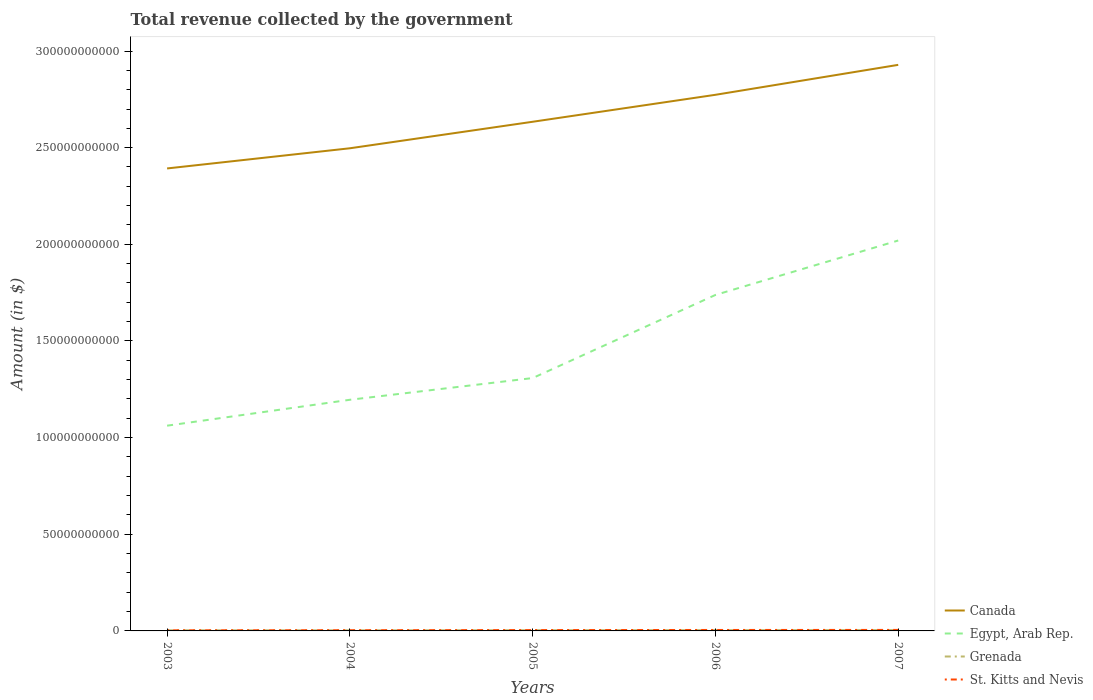How many different coloured lines are there?
Your answer should be compact. 4. Is the number of lines equal to the number of legend labels?
Ensure brevity in your answer.  Yes. Across all years, what is the maximum total revenue collected by the government in St. Kitts and Nevis?
Ensure brevity in your answer.  3.21e+08. In which year was the total revenue collected by the government in St. Kitts and Nevis maximum?
Your answer should be compact. 2003. What is the total total revenue collected by the government in Egypt, Arab Rep. in the graph?
Keep it short and to the point. -1.12e+1. What is the difference between the highest and the second highest total revenue collected by the government in Grenada?
Your response must be concise. 1.28e+08. What is the difference between the highest and the lowest total revenue collected by the government in Canada?
Make the answer very short. 2. Does the graph contain grids?
Keep it short and to the point. No. Where does the legend appear in the graph?
Keep it short and to the point. Bottom right. How are the legend labels stacked?
Provide a short and direct response. Vertical. What is the title of the graph?
Provide a short and direct response. Total revenue collected by the government. Does "Macao" appear as one of the legend labels in the graph?
Your answer should be compact. No. What is the label or title of the Y-axis?
Your answer should be compact. Amount (in $). What is the Amount (in $) in Canada in 2003?
Keep it short and to the point. 2.39e+11. What is the Amount (in $) in Egypt, Arab Rep. in 2003?
Your answer should be compact. 1.06e+11. What is the Amount (in $) in Grenada in 2003?
Offer a terse response. 3.24e+08. What is the Amount (in $) in St. Kitts and Nevis in 2003?
Ensure brevity in your answer.  3.21e+08. What is the Amount (in $) of Canada in 2004?
Provide a succinct answer. 2.50e+11. What is the Amount (in $) of Egypt, Arab Rep. in 2004?
Keep it short and to the point. 1.20e+11. What is the Amount (in $) in Grenada in 2004?
Offer a very short reply. 3.01e+08. What is the Amount (in $) of St. Kitts and Nevis in 2004?
Offer a terse response. 3.65e+08. What is the Amount (in $) of Canada in 2005?
Give a very brief answer. 2.63e+11. What is the Amount (in $) of Egypt, Arab Rep. in 2005?
Provide a short and direct response. 1.31e+11. What is the Amount (in $) of Grenada in 2005?
Keep it short and to the point. 3.60e+08. What is the Amount (in $) in St. Kitts and Nevis in 2005?
Offer a very short reply. 4.34e+08. What is the Amount (in $) of Canada in 2006?
Keep it short and to the point. 2.77e+11. What is the Amount (in $) in Egypt, Arab Rep. in 2006?
Your answer should be very brief. 1.74e+11. What is the Amount (in $) of Grenada in 2006?
Your response must be concise. 3.86e+08. What is the Amount (in $) of St. Kitts and Nevis in 2006?
Your answer should be very brief. 4.92e+08. What is the Amount (in $) of Canada in 2007?
Ensure brevity in your answer.  2.93e+11. What is the Amount (in $) of Egypt, Arab Rep. in 2007?
Provide a short and direct response. 2.02e+11. What is the Amount (in $) of Grenada in 2007?
Ensure brevity in your answer.  4.28e+08. What is the Amount (in $) of St. Kitts and Nevis in 2007?
Keep it short and to the point. 5.16e+08. Across all years, what is the maximum Amount (in $) of Canada?
Offer a very short reply. 2.93e+11. Across all years, what is the maximum Amount (in $) in Egypt, Arab Rep.?
Ensure brevity in your answer.  2.02e+11. Across all years, what is the maximum Amount (in $) in Grenada?
Provide a succinct answer. 4.28e+08. Across all years, what is the maximum Amount (in $) in St. Kitts and Nevis?
Provide a succinct answer. 5.16e+08. Across all years, what is the minimum Amount (in $) of Canada?
Your answer should be very brief. 2.39e+11. Across all years, what is the minimum Amount (in $) of Egypt, Arab Rep.?
Give a very brief answer. 1.06e+11. Across all years, what is the minimum Amount (in $) in Grenada?
Offer a terse response. 3.01e+08. Across all years, what is the minimum Amount (in $) of St. Kitts and Nevis?
Ensure brevity in your answer.  3.21e+08. What is the total Amount (in $) in Canada in the graph?
Your response must be concise. 1.32e+12. What is the total Amount (in $) of Egypt, Arab Rep. in the graph?
Provide a succinct answer. 7.32e+11. What is the total Amount (in $) in Grenada in the graph?
Offer a terse response. 1.80e+09. What is the total Amount (in $) of St. Kitts and Nevis in the graph?
Offer a very short reply. 2.13e+09. What is the difference between the Amount (in $) in Canada in 2003 and that in 2004?
Your response must be concise. -1.04e+1. What is the difference between the Amount (in $) in Egypt, Arab Rep. in 2003 and that in 2004?
Offer a terse response. -1.34e+1. What is the difference between the Amount (in $) in Grenada in 2003 and that in 2004?
Offer a terse response. 2.27e+07. What is the difference between the Amount (in $) in St. Kitts and Nevis in 2003 and that in 2004?
Offer a very short reply. -4.39e+07. What is the difference between the Amount (in $) of Canada in 2003 and that in 2005?
Provide a short and direct response. -2.41e+1. What is the difference between the Amount (in $) of Egypt, Arab Rep. in 2003 and that in 2005?
Offer a very short reply. -2.46e+1. What is the difference between the Amount (in $) of Grenada in 2003 and that in 2005?
Make the answer very short. -3.62e+07. What is the difference between the Amount (in $) of St. Kitts and Nevis in 2003 and that in 2005?
Give a very brief answer. -1.12e+08. What is the difference between the Amount (in $) in Canada in 2003 and that in 2006?
Your response must be concise. -3.81e+1. What is the difference between the Amount (in $) of Egypt, Arab Rep. in 2003 and that in 2006?
Give a very brief answer. -6.76e+1. What is the difference between the Amount (in $) in Grenada in 2003 and that in 2006?
Offer a very short reply. -6.24e+07. What is the difference between the Amount (in $) of St. Kitts and Nevis in 2003 and that in 2006?
Your response must be concise. -1.70e+08. What is the difference between the Amount (in $) in Canada in 2003 and that in 2007?
Give a very brief answer. -5.36e+1. What is the difference between the Amount (in $) of Egypt, Arab Rep. in 2003 and that in 2007?
Keep it short and to the point. -9.58e+1. What is the difference between the Amount (in $) in Grenada in 2003 and that in 2007?
Your response must be concise. -1.05e+08. What is the difference between the Amount (in $) in St. Kitts and Nevis in 2003 and that in 2007?
Provide a short and direct response. -1.95e+08. What is the difference between the Amount (in $) of Canada in 2004 and that in 2005?
Provide a short and direct response. -1.37e+1. What is the difference between the Amount (in $) of Egypt, Arab Rep. in 2004 and that in 2005?
Offer a very short reply. -1.12e+1. What is the difference between the Amount (in $) of Grenada in 2004 and that in 2005?
Your answer should be compact. -5.89e+07. What is the difference between the Amount (in $) of St. Kitts and Nevis in 2004 and that in 2005?
Offer a terse response. -6.85e+07. What is the difference between the Amount (in $) of Canada in 2004 and that in 2006?
Provide a short and direct response. -2.77e+1. What is the difference between the Amount (in $) of Egypt, Arab Rep. in 2004 and that in 2006?
Offer a very short reply. -5.42e+1. What is the difference between the Amount (in $) of Grenada in 2004 and that in 2006?
Keep it short and to the point. -8.51e+07. What is the difference between the Amount (in $) in St. Kitts and Nevis in 2004 and that in 2006?
Provide a short and direct response. -1.26e+08. What is the difference between the Amount (in $) of Canada in 2004 and that in 2007?
Offer a very short reply. -4.32e+1. What is the difference between the Amount (in $) in Egypt, Arab Rep. in 2004 and that in 2007?
Keep it short and to the point. -8.24e+1. What is the difference between the Amount (in $) of Grenada in 2004 and that in 2007?
Offer a very short reply. -1.28e+08. What is the difference between the Amount (in $) in St. Kitts and Nevis in 2004 and that in 2007?
Offer a very short reply. -1.51e+08. What is the difference between the Amount (in $) in Canada in 2005 and that in 2006?
Ensure brevity in your answer.  -1.40e+1. What is the difference between the Amount (in $) in Egypt, Arab Rep. in 2005 and that in 2006?
Ensure brevity in your answer.  -4.30e+1. What is the difference between the Amount (in $) in Grenada in 2005 and that in 2006?
Provide a short and direct response. -2.62e+07. What is the difference between the Amount (in $) of St. Kitts and Nevis in 2005 and that in 2006?
Provide a short and direct response. -5.77e+07. What is the difference between the Amount (in $) in Canada in 2005 and that in 2007?
Your answer should be very brief. -2.94e+1. What is the difference between the Amount (in $) in Egypt, Arab Rep. in 2005 and that in 2007?
Provide a succinct answer. -7.12e+1. What is the difference between the Amount (in $) of Grenada in 2005 and that in 2007?
Make the answer very short. -6.86e+07. What is the difference between the Amount (in $) of St. Kitts and Nevis in 2005 and that in 2007?
Your answer should be compact. -8.23e+07. What is the difference between the Amount (in $) in Canada in 2006 and that in 2007?
Your answer should be very brief. -1.55e+1. What is the difference between the Amount (in $) of Egypt, Arab Rep. in 2006 and that in 2007?
Make the answer very short. -2.82e+1. What is the difference between the Amount (in $) of Grenada in 2006 and that in 2007?
Offer a terse response. -4.24e+07. What is the difference between the Amount (in $) in St. Kitts and Nevis in 2006 and that in 2007?
Your response must be concise. -2.46e+07. What is the difference between the Amount (in $) in Canada in 2003 and the Amount (in $) in Egypt, Arab Rep. in 2004?
Offer a very short reply. 1.20e+11. What is the difference between the Amount (in $) in Canada in 2003 and the Amount (in $) in Grenada in 2004?
Offer a very short reply. 2.39e+11. What is the difference between the Amount (in $) of Canada in 2003 and the Amount (in $) of St. Kitts and Nevis in 2004?
Offer a terse response. 2.39e+11. What is the difference between the Amount (in $) of Egypt, Arab Rep. in 2003 and the Amount (in $) of Grenada in 2004?
Your answer should be very brief. 1.06e+11. What is the difference between the Amount (in $) in Egypt, Arab Rep. in 2003 and the Amount (in $) in St. Kitts and Nevis in 2004?
Keep it short and to the point. 1.06e+11. What is the difference between the Amount (in $) in Grenada in 2003 and the Amount (in $) in St. Kitts and Nevis in 2004?
Make the answer very short. -4.17e+07. What is the difference between the Amount (in $) in Canada in 2003 and the Amount (in $) in Egypt, Arab Rep. in 2005?
Offer a terse response. 1.08e+11. What is the difference between the Amount (in $) in Canada in 2003 and the Amount (in $) in Grenada in 2005?
Provide a succinct answer. 2.39e+11. What is the difference between the Amount (in $) in Canada in 2003 and the Amount (in $) in St. Kitts and Nevis in 2005?
Your answer should be very brief. 2.39e+11. What is the difference between the Amount (in $) of Egypt, Arab Rep. in 2003 and the Amount (in $) of Grenada in 2005?
Your answer should be compact. 1.06e+11. What is the difference between the Amount (in $) of Egypt, Arab Rep. in 2003 and the Amount (in $) of St. Kitts and Nevis in 2005?
Make the answer very short. 1.06e+11. What is the difference between the Amount (in $) in Grenada in 2003 and the Amount (in $) in St. Kitts and Nevis in 2005?
Make the answer very short. -1.10e+08. What is the difference between the Amount (in $) of Canada in 2003 and the Amount (in $) of Egypt, Arab Rep. in 2006?
Make the answer very short. 6.54e+1. What is the difference between the Amount (in $) of Canada in 2003 and the Amount (in $) of Grenada in 2006?
Your response must be concise. 2.39e+11. What is the difference between the Amount (in $) of Canada in 2003 and the Amount (in $) of St. Kitts and Nevis in 2006?
Provide a succinct answer. 2.39e+11. What is the difference between the Amount (in $) of Egypt, Arab Rep. in 2003 and the Amount (in $) of Grenada in 2006?
Ensure brevity in your answer.  1.06e+11. What is the difference between the Amount (in $) in Egypt, Arab Rep. in 2003 and the Amount (in $) in St. Kitts and Nevis in 2006?
Provide a succinct answer. 1.06e+11. What is the difference between the Amount (in $) in Grenada in 2003 and the Amount (in $) in St. Kitts and Nevis in 2006?
Your answer should be compact. -1.68e+08. What is the difference between the Amount (in $) in Canada in 2003 and the Amount (in $) in Egypt, Arab Rep. in 2007?
Provide a succinct answer. 3.73e+1. What is the difference between the Amount (in $) of Canada in 2003 and the Amount (in $) of Grenada in 2007?
Provide a succinct answer. 2.39e+11. What is the difference between the Amount (in $) in Canada in 2003 and the Amount (in $) in St. Kitts and Nevis in 2007?
Keep it short and to the point. 2.39e+11. What is the difference between the Amount (in $) in Egypt, Arab Rep. in 2003 and the Amount (in $) in Grenada in 2007?
Provide a succinct answer. 1.06e+11. What is the difference between the Amount (in $) in Egypt, Arab Rep. in 2003 and the Amount (in $) in St. Kitts and Nevis in 2007?
Provide a short and direct response. 1.06e+11. What is the difference between the Amount (in $) in Grenada in 2003 and the Amount (in $) in St. Kitts and Nevis in 2007?
Offer a very short reply. -1.92e+08. What is the difference between the Amount (in $) in Canada in 2004 and the Amount (in $) in Egypt, Arab Rep. in 2005?
Offer a terse response. 1.19e+11. What is the difference between the Amount (in $) of Canada in 2004 and the Amount (in $) of Grenada in 2005?
Your answer should be compact. 2.49e+11. What is the difference between the Amount (in $) in Canada in 2004 and the Amount (in $) in St. Kitts and Nevis in 2005?
Provide a succinct answer. 2.49e+11. What is the difference between the Amount (in $) of Egypt, Arab Rep. in 2004 and the Amount (in $) of Grenada in 2005?
Provide a short and direct response. 1.19e+11. What is the difference between the Amount (in $) in Egypt, Arab Rep. in 2004 and the Amount (in $) in St. Kitts and Nevis in 2005?
Offer a terse response. 1.19e+11. What is the difference between the Amount (in $) of Grenada in 2004 and the Amount (in $) of St. Kitts and Nevis in 2005?
Provide a succinct answer. -1.33e+08. What is the difference between the Amount (in $) in Canada in 2004 and the Amount (in $) in Egypt, Arab Rep. in 2006?
Your answer should be very brief. 7.59e+1. What is the difference between the Amount (in $) in Canada in 2004 and the Amount (in $) in Grenada in 2006?
Keep it short and to the point. 2.49e+11. What is the difference between the Amount (in $) in Canada in 2004 and the Amount (in $) in St. Kitts and Nevis in 2006?
Keep it short and to the point. 2.49e+11. What is the difference between the Amount (in $) in Egypt, Arab Rep. in 2004 and the Amount (in $) in Grenada in 2006?
Give a very brief answer. 1.19e+11. What is the difference between the Amount (in $) in Egypt, Arab Rep. in 2004 and the Amount (in $) in St. Kitts and Nevis in 2006?
Your answer should be very brief. 1.19e+11. What is the difference between the Amount (in $) of Grenada in 2004 and the Amount (in $) of St. Kitts and Nevis in 2006?
Your answer should be very brief. -1.91e+08. What is the difference between the Amount (in $) of Canada in 2004 and the Amount (in $) of Egypt, Arab Rep. in 2007?
Your answer should be compact. 4.77e+1. What is the difference between the Amount (in $) in Canada in 2004 and the Amount (in $) in Grenada in 2007?
Provide a succinct answer. 2.49e+11. What is the difference between the Amount (in $) in Canada in 2004 and the Amount (in $) in St. Kitts and Nevis in 2007?
Offer a very short reply. 2.49e+11. What is the difference between the Amount (in $) of Egypt, Arab Rep. in 2004 and the Amount (in $) of Grenada in 2007?
Your response must be concise. 1.19e+11. What is the difference between the Amount (in $) in Egypt, Arab Rep. in 2004 and the Amount (in $) in St. Kitts and Nevis in 2007?
Your response must be concise. 1.19e+11. What is the difference between the Amount (in $) in Grenada in 2004 and the Amount (in $) in St. Kitts and Nevis in 2007?
Offer a terse response. -2.15e+08. What is the difference between the Amount (in $) in Canada in 2005 and the Amount (in $) in Egypt, Arab Rep. in 2006?
Make the answer very short. 8.96e+1. What is the difference between the Amount (in $) of Canada in 2005 and the Amount (in $) of Grenada in 2006?
Offer a very short reply. 2.63e+11. What is the difference between the Amount (in $) of Canada in 2005 and the Amount (in $) of St. Kitts and Nevis in 2006?
Your answer should be compact. 2.63e+11. What is the difference between the Amount (in $) in Egypt, Arab Rep. in 2005 and the Amount (in $) in Grenada in 2006?
Make the answer very short. 1.30e+11. What is the difference between the Amount (in $) of Egypt, Arab Rep. in 2005 and the Amount (in $) of St. Kitts and Nevis in 2006?
Your answer should be very brief. 1.30e+11. What is the difference between the Amount (in $) in Grenada in 2005 and the Amount (in $) in St. Kitts and Nevis in 2006?
Your response must be concise. -1.32e+08. What is the difference between the Amount (in $) of Canada in 2005 and the Amount (in $) of Egypt, Arab Rep. in 2007?
Make the answer very short. 6.14e+1. What is the difference between the Amount (in $) of Canada in 2005 and the Amount (in $) of Grenada in 2007?
Provide a succinct answer. 2.63e+11. What is the difference between the Amount (in $) in Canada in 2005 and the Amount (in $) in St. Kitts and Nevis in 2007?
Offer a terse response. 2.63e+11. What is the difference between the Amount (in $) of Egypt, Arab Rep. in 2005 and the Amount (in $) of Grenada in 2007?
Ensure brevity in your answer.  1.30e+11. What is the difference between the Amount (in $) of Egypt, Arab Rep. in 2005 and the Amount (in $) of St. Kitts and Nevis in 2007?
Offer a very short reply. 1.30e+11. What is the difference between the Amount (in $) of Grenada in 2005 and the Amount (in $) of St. Kitts and Nevis in 2007?
Make the answer very short. -1.56e+08. What is the difference between the Amount (in $) in Canada in 2006 and the Amount (in $) in Egypt, Arab Rep. in 2007?
Keep it short and to the point. 7.54e+1. What is the difference between the Amount (in $) of Canada in 2006 and the Amount (in $) of Grenada in 2007?
Your answer should be very brief. 2.77e+11. What is the difference between the Amount (in $) of Canada in 2006 and the Amount (in $) of St. Kitts and Nevis in 2007?
Your response must be concise. 2.77e+11. What is the difference between the Amount (in $) of Egypt, Arab Rep. in 2006 and the Amount (in $) of Grenada in 2007?
Offer a very short reply. 1.73e+11. What is the difference between the Amount (in $) of Egypt, Arab Rep. in 2006 and the Amount (in $) of St. Kitts and Nevis in 2007?
Offer a very short reply. 1.73e+11. What is the difference between the Amount (in $) in Grenada in 2006 and the Amount (in $) in St. Kitts and Nevis in 2007?
Give a very brief answer. -1.30e+08. What is the average Amount (in $) of Canada per year?
Your answer should be very brief. 2.65e+11. What is the average Amount (in $) of Egypt, Arab Rep. per year?
Offer a terse response. 1.46e+11. What is the average Amount (in $) in Grenada per year?
Give a very brief answer. 3.60e+08. What is the average Amount (in $) in St. Kitts and Nevis per year?
Offer a terse response. 4.26e+08. In the year 2003, what is the difference between the Amount (in $) in Canada and Amount (in $) in Egypt, Arab Rep.?
Make the answer very short. 1.33e+11. In the year 2003, what is the difference between the Amount (in $) in Canada and Amount (in $) in Grenada?
Offer a very short reply. 2.39e+11. In the year 2003, what is the difference between the Amount (in $) of Canada and Amount (in $) of St. Kitts and Nevis?
Your answer should be compact. 2.39e+11. In the year 2003, what is the difference between the Amount (in $) in Egypt, Arab Rep. and Amount (in $) in Grenada?
Your response must be concise. 1.06e+11. In the year 2003, what is the difference between the Amount (in $) in Egypt, Arab Rep. and Amount (in $) in St. Kitts and Nevis?
Keep it short and to the point. 1.06e+11. In the year 2003, what is the difference between the Amount (in $) of Grenada and Amount (in $) of St. Kitts and Nevis?
Ensure brevity in your answer.  2.20e+06. In the year 2004, what is the difference between the Amount (in $) of Canada and Amount (in $) of Egypt, Arab Rep.?
Give a very brief answer. 1.30e+11. In the year 2004, what is the difference between the Amount (in $) of Canada and Amount (in $) of Grenada?
Provide a succinct answer. 2.49e+11. In the year 2004, what is the difference between the Amount (in $) of Canada and Amount (in $) of St. Kitts and Nevis?
Make the answer very short. 2.49e+11. In the year 2004, what is the difference between the Amount (in $) in Egypt, Arab Rep. and Amount (in $) in Grenada?
Your response must be concise. 1.19e+11. In the year 2004, what is the difference between the Amount (in $) of Egypt, Arab Rep. and Amount (in $) of St. Kitts and Nevis?
Provide a short and direct response. 1.19e+11. In the year 2004, what is the difference between the Amount (in $) in Grenada and Amount (in $) in St. Kitts and Nevis?
Make the answer very short. -6.44e+07. In the year 2005, what is the difference between the Amount (in $) in Canada and Amount (in $) in Egypt, Arab Rep.?
Your answer should be compact. 1.33e+11. In the year 2005, what is the difference between the Amount (in $) of Canada and Amount (in $) of Grenada?
Your response must be concise. 2.63e+11. In the year 2005, what is the difference between the Amount (in $) of Canada and Amount (in $) of St. Kitts and Nevis?
Your response must be concise. 2.63e+11. In the year 2005, what is the difference between the Amount (in $) of Egypt, Arab Rep. and Amount (in $) of Grenada?
Your answer should be very brief. 1.30e+11. In the year 2005, what is the difference between the Amount (in $) of Egypt, Arab Rep. and Amount (in $) of St. Kitts and Nevis?
Offer a terse response. 1.30e+11. In the year 2005, what is the difference between the Amount (in $) in Grenada and Amount (in $) in St. Kitts and Nevis?
Give a very brief answer. -7.40e+07. In the year 2006, what is the difference between the Amount (in $) in Canada and Amount (in $) in Egypt, Arab Rep.?
Your answer should be compact. 1.04e+11. In the year 2006, what is the difference between the Amount (in $) of Canada and Amount (in $) of Grenada?
Make the answer very short. 2.77e+11. In the year 2006, what is the difference between the Amount (in $) in Canada and Amount (in $) in St. Kitts and Nevis?
Offer a terse response. 2.77e+11. In the year 2006, what is the difference between the Amount (in $) in Egypt, Arab Rep. and Amount (in $) in Grenada?
Ensure brevity in your answer.  1.73e+11. In the year 2006, what is the difference between the Amount (in $) of Egypt, Arab Rep. and Amount (in $) of St. Kitts and Nevis?
Your answer should be compact. 1.73e+11. In the year 2006, what is the difference between the Amount (in $) of Grenada and Amount (in $) of St. Kitts and Nevis?
Make the answer very short. -1.06e+08. In the year 2007, what is the difference between the Amount (in $) of Canada and Amount (in $) of Egypt, Arab Rep.?
Your response must be concise. 9.09e+1. In the year 2007, what is the difference between the Amount (in $) of Canada and Amount (in $) of Grenada?
Provide a succinct answer. 2.92e+11. In the year 2007, what is the difference between the Amount (in $) of Canada and Amount (in $) of St. Kitts and Nevis?
Your answer should be very brief. 2.92e+11. In the year 2007, what is the difference between the Amount (in $) of Egypt, Arab Rep. and Amount (in $) of Grenada?
Provide a short and direct response. 2.02e+11. In the year 2007, what is the difference between the Amount (in $) in Egypt, Arab Rep. and Amount (in $) in St. Kitts and Nevis?
Provide a succinct answer. 2.01e+11. In the year 2007, what is the difference between the Amount (in $) of Grenada and Amount (in $) of St. Kitts and Nevis?
Give a very brief answer. -8.77e+07. What is the ratio of the Amount (in $) of Canada in 2003 to that in 2004?
Provide a succinct answer. 0.96. What is the ratio of the Amount (in $) of Egypt, Arab Rep. in 2003 to that in 2004?
Your answer should be compact. 0.89. What is the ratio of the Amount (in $) in Grenada in 2003 to that in 2004?
Offer a very short reply. 1.08. What is the ratio of the Amount (in $) in St. Kitts and Nevis in 2003 to that in 2004?
Make the answer very short. 0.88. What is the ratio of the Amount (in $) in Canada in 2003 to that in 2005?
Ensure brevity in your answer.  0.91. What is the ratio of the Amount (in $) in Egypt, Arab Rep. in 2003 to that in 2005?
Give a very brief answer. 0.81. What is the ratio of the Amount (in $) in Grenada in 2003 to that in 2005?
Your response must be concise. 0.9. What is the ratio of the Amount (in $) in St. Kitts and Nevis in 2003 to that in 2005?
Provide a succinct answer. 0.74. What is the ratio of the Amount (in $) in Canada in 2003 to that in 2006?
Ensure brevity in your answer.  0.86. What is the ratio of the Amount (in $) in Egypt, Arab Rep. in 2003 to that in 2006?
Offer a very short reply. 0.61. What is the ratio of the Amount (in $) of Grenada in 2003 to that in 2006?
Your response must be concise. 0.84. What is the ratio of the Amount (in $) of St. Kitts and Nevis in 2003 to that in 2006?
Offer a terse response. 0.65. What is the ratio of the Amount (in $) of Canada in 2003 to that in 2007?
Provide a succinct answer. 0.82. What is the ratio of the Amount (in $) in Egypt, Arab Rep. in 2003 to that in 2007?
Keep it short and to the point. 0.53. What is the ratio of the Amount (in $) of Grenada in 2003 to that in 2007?
Keep it short and to the point. 0.76. What is the ratio of the Amount (in $) in St. Kitts and Nevis in 2003 to that in 2007?
Keep it short and to the point. 0.62. What is the ratio of the Amount (in $) of Canada in 2004 to that in 2005?
Offer a very short reply. 0.95. What is the ratio of the Amount (in $) in Egypt, Arab Rep. in 2004 to that in 2005?
Keep it short and to the point. 0.91. What is the ratio of the Amount (in $) in Grenada in 2004 to that in 2005?
Ensure brevity in your answer.  0.84. What is the ratio of the Amount (in $) in St. Kitts and Nevis in 2004 to that in 2005?
Keep it short and to the point. 0.84. What is the ratio of the Amount (in $) of Canada in 2004 to that in 2006?
Provide a short and direct response. 0.9. What is the ratio of the Amount (in $) of Egypt, Arab Rep. in 2004 to that in 2006?
Give a very brief answer. 0.69. What is the ratio of the Amount (in $) of Grenada in 2004 to that in 2006?
Offer a terse response. 0.78. What is the ratio of the Amount (in $) in St. Kitts and Nevis in 2004 to that in 2006?
Keep it short and to the point. 0.74. What is the ratio of the Amount (in $) in Canada in 2004 to that in 2007?
Provide a short and direct response. 0.85. What is the ratio of the Amount (in $) in Egypt, Arab Rep. in 2004 to that in 2007?
Your answer should be compact. 0.59. What is the ratio of the Amount (in $) of Grenada in 2004 to that in 2007?
Offer a very short reply. 0.7. What is the ratio of the Amount (in $) in St. Kitts and Nevis in 2004 to that in 2007?
Give a very brief answer. 0.71. What is the ratio of the Amount (in $) of Canada in 2005 to that in 2006?
Provide a succinct answer. 0.95. What is the ratio of the Amount (in $) of Egypt, Arab Rep. in 2005 to that in 2006?
Keep it short and to the point. 0.75. What is the ratio of the Amount (in $) in Grenada in 2005 to that in 2006?
Offer a terse response. 0.93. What is the ratio of the Amount (in $) of St. Kitts and Nevis in 2005 to that in 2006?
Your answer should be very brief. 0.88. What is the ratio of the Amount (in $) of Canada in 2005 to that in 2007?
Ensure brevity in your answer.  0.9. What is the ratio of the Amount (in $) of Egypt, Arab Rep. in 2005 to that in 2007?
Keep it short and to the point. 0.65. What is the ratio of the Amount (in $) in Grenada in 2005 to that in 2007?
Your answer should be compact. 0.84. What is the ratio of the Amount (in $) of St. Kitts and Nevis in 2005 to that in 2007?
Offer a very short reply. 0.84. What is the ratio of the Amount (in $) in Canada in 2006 to that in 2007?
Your answer should be very brief. 0.95. What is the ratio of the Amount (in $) of Egypt, Arab Rep. in 2006 to that in 2007?
Ensure brevity in your answer.  0.86. What is the ratio of the Amount (in $) in Grenada in 2006 to that in 2007?
Give a very brief answer. 0.9. What is the ratio of the Amount (in $) of St. Kitts and Nevis in 2006 to that in 2007?
Provide a short and direct response. 0.95. What is the difference between the highest and the second highest Amount (in $) in Canada?
Provide a succinct answer. 1.55e+1. What is the difference between the highest and the second highest Amount (in $) of Egypt, Arab Rep.?
Offer a terse response. 2.82e+1. What is the difference between the highest and the second highest Amount (in $) in Grenada?
Keep it short and to the point. 4.24e+07. What is the difference between the highest and the second highest Amount (in $) in St. Kitts and Nevis?
Make the answer very short. 2.46e+07. What is the difference between the highest and the lowest Amount (in $) in Canada?
Give a very brief answer. 5.36e+1. What is the difference between the highest and the lowest Amount (in $) of Egypt, Arab Rep.?
Your answer should be very brief. 9.58e+1. What is the difference between the highest and the lowest Amount (in $) in Grenada?
Offer a very short reply. 1.28e+08. What is the difference between the highest and the lowest Amount (in $) in St. Kitts and Nevis?
Keep it short and to the point. 1.95e+08. 